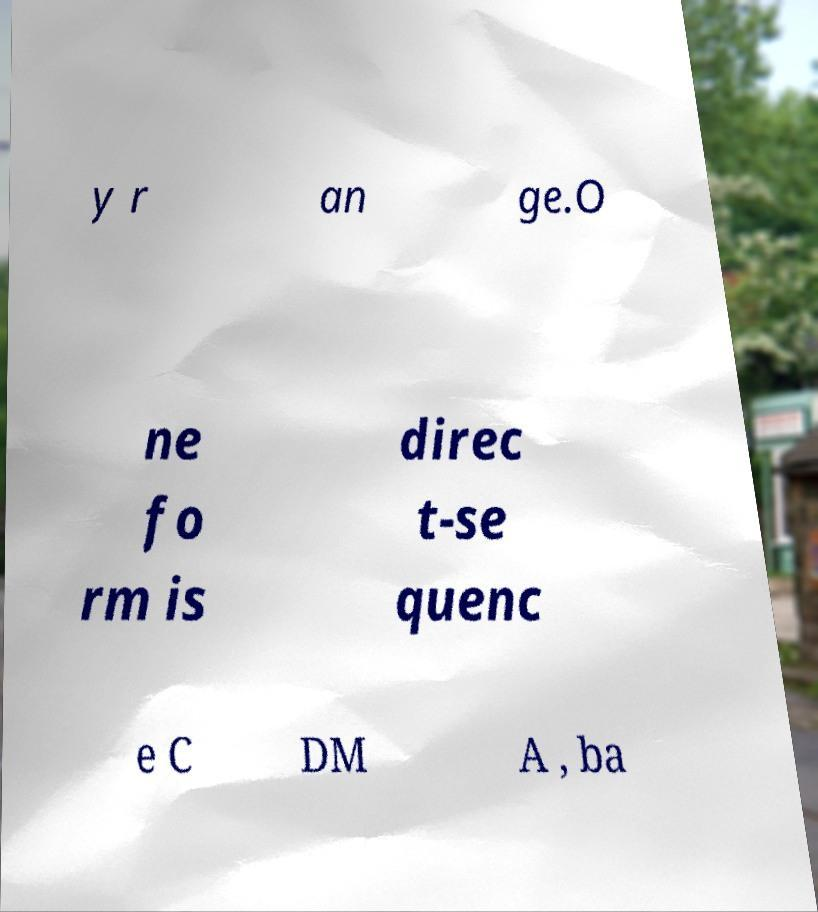Can you accurately transcribe the text from the provided image for me? y r an ge.O ne fo rm is direc t-se quenc e C DM A , ba 